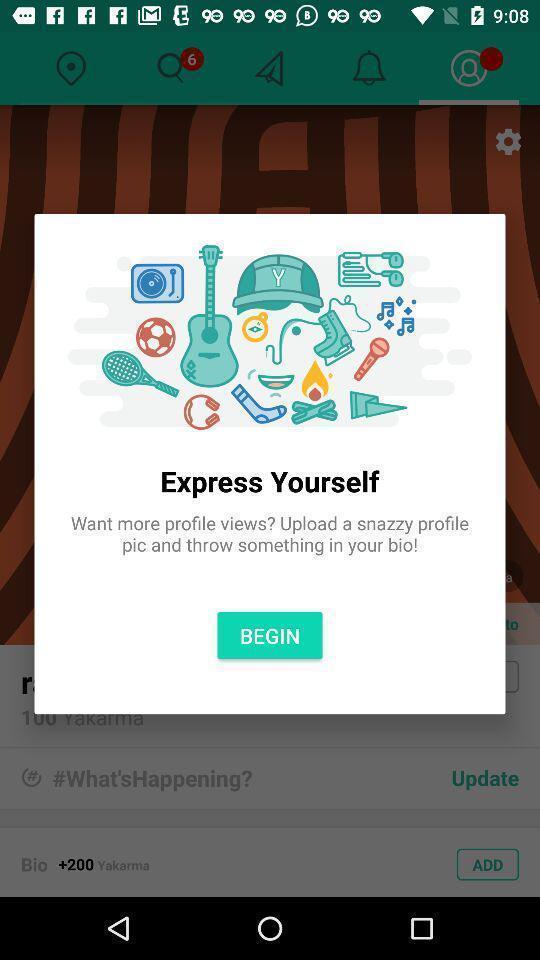What is the overall content of this screenshot? Pop-up displaying the begin option. 